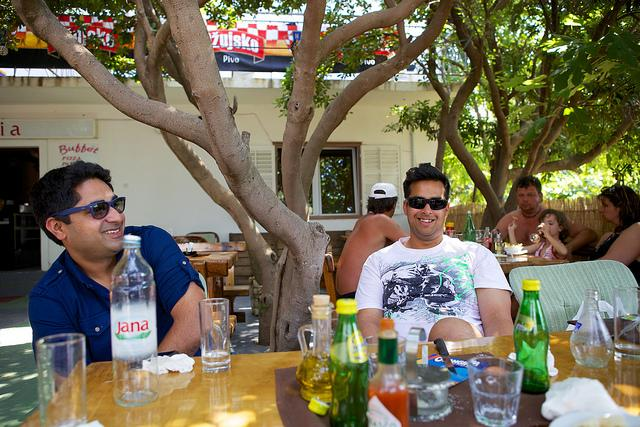What establishment is located behind the people?

Choices:
A) motel
B) pub
C) restaurant
D) store restaurant 